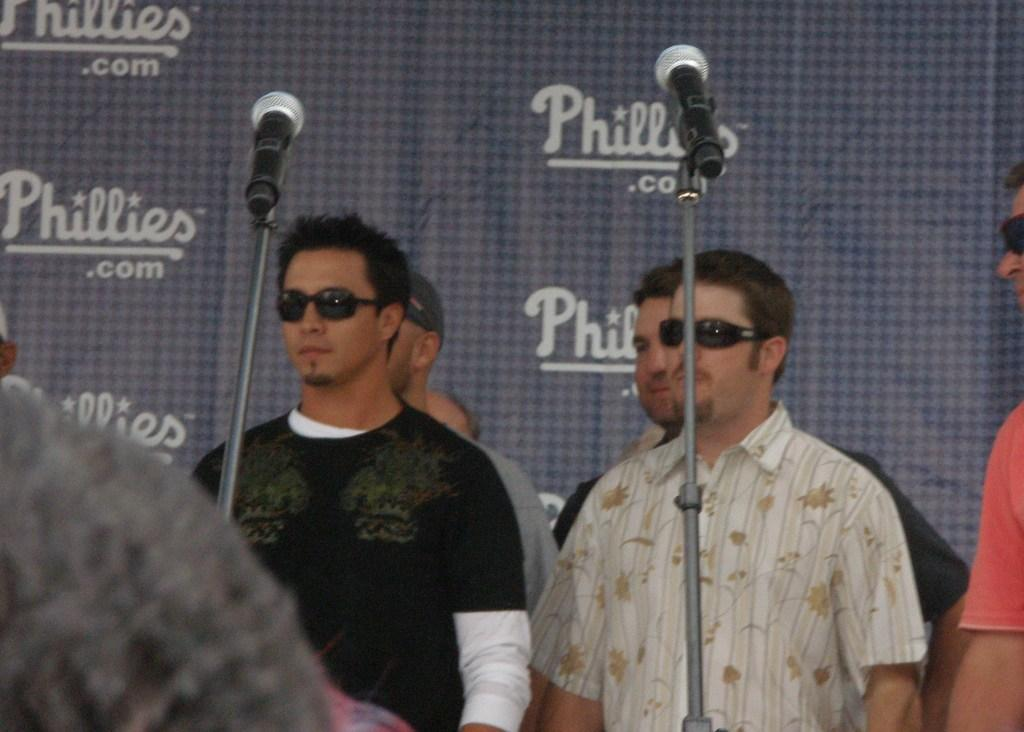Who or what can be seen in the image? There are people in the image. What are the people doing or interacting with in the image? The people are in front of poles with microphones. Is there any additional information provided by the image? Yes, there is a banner with text visible in the image. Are there any carriages visible in the image? No, there are no carriages present in the image. What type of development is being discussed on the banner in the image? The provided facts do not mention any specific development being discussed on the banner; it only states that there is a banner with text visible. 